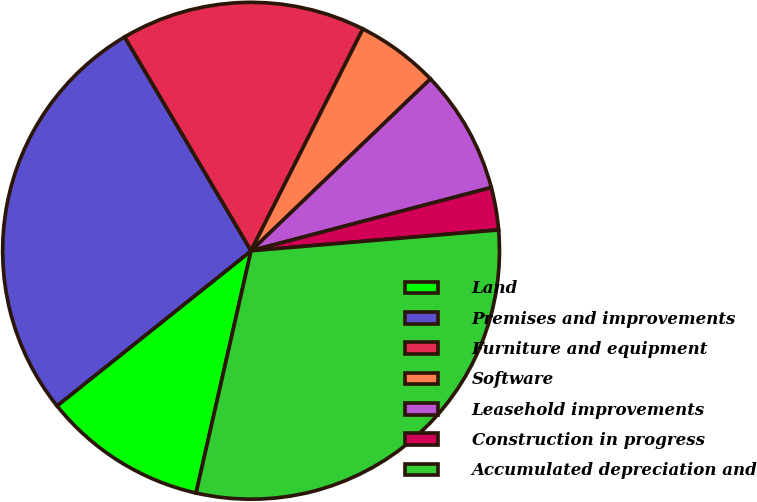Convert chart to OTSL. <chart><loc_0><loc_0><loc_500><loc_500><pie_chart><fcel>Land<fcel>Premises and improvements<fcel>Furniture and equipment<fcel>Software<fcel>Leasehold improvements<fcel>Construction in progress<fcel>Accumulated depreciation and<nl><fcel>10.72%<fcel>27.23%<fcel>15.93%<fcel>5.41%<fcel>8.06%<fcel>2.76%<fcel>29.89%<nl></chart> 